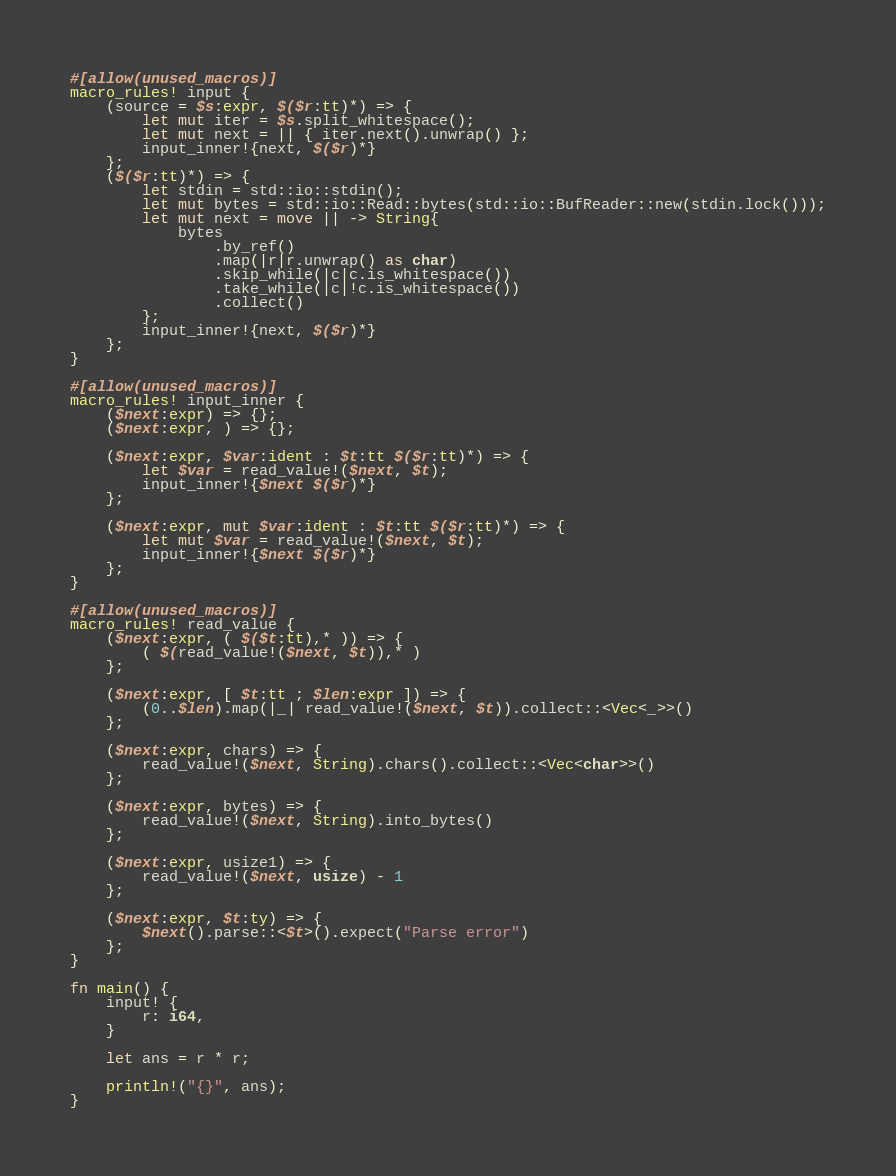Convert code to text. <code><loc_0><loc_0><loc_500><loc_500><_Rust_>#[allow(unused_macros)]
macro_rules! input {
    (source = $s:expr, $($r:tt)*) => {
        let mut iter = $s.split_whitespace();
        let mut next = || { iter.next().unwrap() };
        input_inner!{next, $($r)*}
    };
    ($($r:tt)*) => {
        let stdin = std::io::stdin();
        let mut bytes = std::io::Read::bytes(std::io::BufReader::new(stdin.lock()));
        let mut next = move || -> String{
            bytes
                .by_ref()
                .map(|r|r.unwrap() as char)
                .skip_while(|c|c.is_whitespace())
                .take_while(|c|!c.is_whitespace())
                .collect()
        };
        input_inner!{next, $($r)*}
    };
}

#[allow(unused_macros)]
macro_rules! input_inner {
    ($next:expr) => {};
    ($next:expr, ) => {};

    ($next:expr, $var:ident : $t:tt $($r:tt)*) => {
        let $var = read_value!($next, $t);
        input_inner!{$next $($r)*}
    };

    ($next:expr, mut $var:ident : $t:tt $($r:tt)*) => {
        let mut $var = read_value!($next, $t);
        input_inner!{$next $($r)*}
    };
}

#[allow(unused_macros)]
macro_rules! read_value {
    ($next:expr, ( $($t:tt),* )) => {
        ( $(read_value!($next, $t)),* )
    };

    ($next:expr, [ $t:tt ; $len:expr ]) => {
        (0..$len).map(|_| read_value!($next, $t)).collect::<Vec<_>>()
    };

    ($next:expr, chars) => {
        read_value!($next, String).chars().collect::<Vec<char>>()
    };

    ($next:expr, bytes) => {
        read_value!($next, String).into_bytes()
    };

    ($next:expr, usize1) => {
        read_value!($next, usize) - 1
    };

    ($next:expr, $t:ty) => {
        $next().parse::<$t>().expect("Parse error")
    };
}

fn main() {
    input! {
        r: i64,
    }

    let ans = r * r;

    println!("{}", ans);
}
</code> 